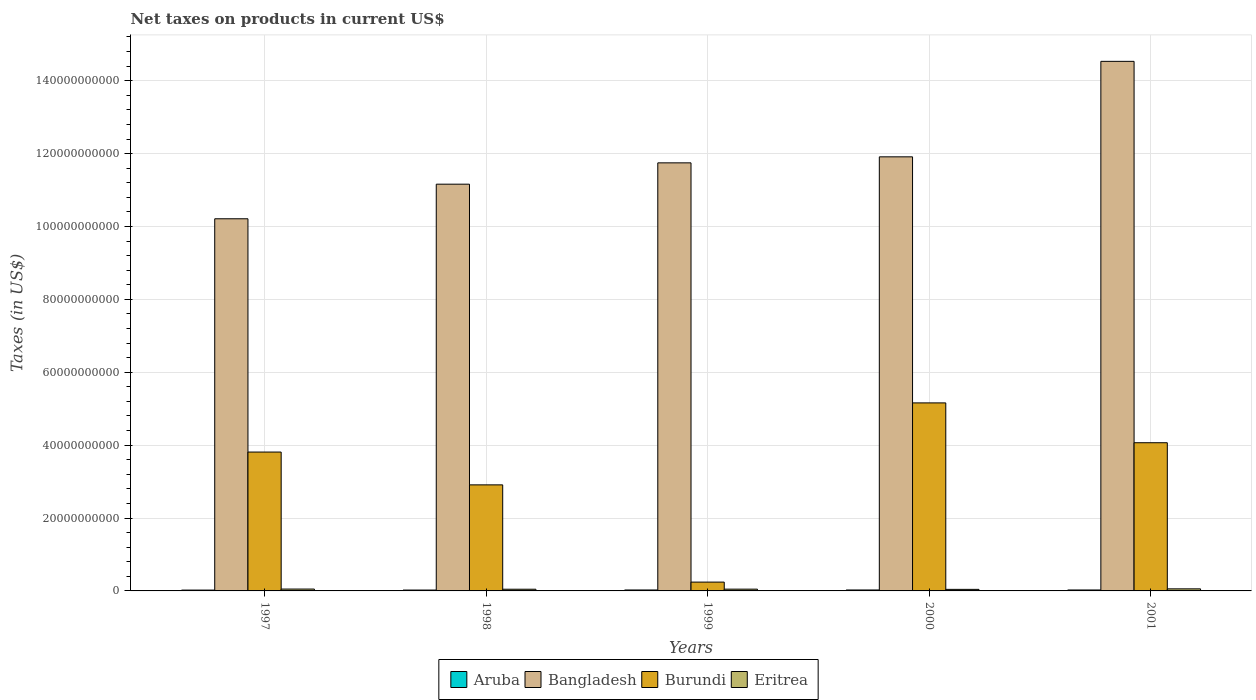How many groups of bars are there?
Offer a terse response. 5. Are the number of bars per tick equal to the number of legend labels?
Keep it short and to the point. Yes. Are the number of bars on each tick of the X-axis equal?
Your answer should be very brief. Yes. How many bars are there on the 5th tick from the left?
Offer a very short reply. 4. How many bars are there on the 4th tick from the right?
Make the answer very short. 4. What is the label of the 2nd group of bars from the left?
Keep it short and to the point. 1998. What is the net taxes on products in Eritrea in 2000?
Provide a short and direct response. 4.28e+08. Across all years, what is the maximum net taxes on products in Burundi?
Give a very brief answer. 5.16e+1. Across all years, what is the minimum net taxes on products in Bangladesh?
Provide a short and direct response. 1.02e+11. In which year was the net taxes on products in Bangladesh maximum?
Provide a short and direct response. 2001. In which year was the net taxes on products in Aruba minimum?
Your answer should be compact. 1997. What is the total net taxes on products in Aruba in the graph?
Make the answer very short. 1.24e+09. What is the difference between the net taxes on products in Bangladesh in 1999 and that in 2001?
Keep it short and to the point. -2.78e+1. What is the difference between the net taxes on products in Burundi in 2001 and the net taxes on products in Eritrea in 1999?
Make the answer very short. 4.02e+1. What is the average net taxes on products in Burundi per year?
Provide a short and direct response. 3.24e+1. In the year 2000, what is the difference between the net taxes on products in Burundi and net taxes on products in Aruba?
Ensure brevity in your answer.  5.13e+1. In how many years, is the net taxes on products in Bangladesh greater than 20000000000 US$?
Make the answer very short. 5. What is the ratio of the net taxes on products in Eritrea in 1998 to that in 2000?
Your answer should be compact. 1.09. Is the net taxes on products in Burundi in 1999 less than that in 2000?
Keep it short and to the point. Yes. What is the difference between the highest and the second highest net taxes on products in Burundi?
Provide a succinct answer. 1.09e+1. What is the difference between the highest and the lowest net taxes on products in Burundi?
Ensure brevity in your answer.  4.92e+1. In how many years, is the net taxes on products in Burundi greater than the average net taxes on products in Burundi taken over all years?
Your answer should be very brief. 3. Is the sum of the net taxes on products in Burundi in 1997 and 1998 greater than the maximum net taxes on products in Bangladesh across all years?
Offer a terse response. No. Is it the case that in every year, the sum of the net taxes on products in Eritrea and net taxes on products in Bangladesh is greater than the sum of net taxes on products in Burundi and net taxes on products in Aruba?
Make the answer very short. Yes. What does the 4th bar from the left in 1997 represents?
Your response must be concise. Eritrea. Is it the case that in every year, the sum of the net taxes on products in Aruba and net taxes on products in Bangladesh is greater than the net taxes on products in Eritrea?
Give a very brief answer. Yes. How many bars are there?
Give a very brief answer. 20. Are all the bars in the graph horizontal?
Offer a terse response. No. How many years are there in the graph?
Your answer should be compact. 5. Are the values on the major ticks of Y-axis written in scientific E-notation?
Your answer should be compact. No. Does the graph contain any zero values?
Ensure brevity in your answer.  No. How many legend labels are there?
Provide a short and direct response. 4. How are the legend labels stacked?
Offer a very short reply. Horizontal. What is the title of the graph?
Your answer should be very brief. Net taxes on products in current US$. What is the label or title of the X-axis?
Make the answer very short. Years. What is the label or title of the Y-axis?
Make the answer very short. Taxes (in US$). What is the Taxes (in US$) in Aruba in 1997?
Your answer should be very brief. 2.29e+08. What is the Taxes (in US$) in Bangladesh in 1997?
Make the answer very short. 1.02e+11. What is the Taxes (in US$) of Burundi in 1997?
Provide a succinct answer. 3.81e+1. What is the Taxes (in US$) of Eritrea in 1997?
Give a very brief answer. 5.11e+08. What is the Taxes (in US$) in Aruba in 1998?
Offer a very short reply. 2.38e+08. What is the Taxes (in US$) in Bangladesh in 1998?
Your answer should be very brief. 1.12e+11. What is the Taxes (in US$) in Burundi in 1998?
Offer a terse response. 2.91e+1. What is the Taxes (in US$) of Eritrea in 1998?
Your response must be concise. 4.65e+08. What is the Taxes (in US$) of Aruba in 1999?
Your answer should be very brief. 2.59e+08. What is the Taxes (in US$) of Bangladesh in 1999?
Your response must be concise. 1.17e+11. What is the Taxes (in US$) in Burundi in 1999?
Your answer should be very brief. 2.42e+09. What is the Taxes (in US$) in Eritrea in 1999?
Offer a terse response. 4.88e+08. What is the Taxes (in US$) in Aruba in 2000?
Offer a terse response. 2.59e+08. What is the Taxes (in US$) of Bangladesh in 2000?
Ensure brevity in your answer.  1.19e+11. What is the Taxes (in US$) of Burundi in 2000?
Give a very brief answer. 5.16e+1. What is the Taxes (in US$) in Eritrea in 2000?
Your response must be concise. 4.28e+08. What is the Taxes (in US$) in Aruba in 2001?
Offer a terse response. 2.58e+08. What is the Taxes (in US$) in Bangladesh in 2001?
Your answer should be very brief. 1.45e+11. What is the Taxes (in US$) in Burundi in 2001?
Your response must be concise. 4.07e+1. What is the Taxes (in US$) of Eritrea in 2001?
Ensure brevity in your answer.  5.68e+08. Across all years, what is the maximum Taxes (in US$) of Aruba?
Provide a succinct answer. 2.59e+08. Across all years, what is the maximum Taxes (in US$) in Bangladesh?
Provide a short and direct response. 1.45e+11. Across all years, what is the maximum Taxes (in US$) in Burundi?
Your answer should be very brief. 5.16e+1. Across all years, what is the maximum Taxes (in US$) in Eritrea?
Offer a terse response. 5.68e+08. Across all years, what is the minimum Taxes (in US$) in Aruba?
Your answer should be compact. 2.29e+08. Across all years, what is the minimum Taxes (in US$) in Bangladesh?
Ensure brevity in your answer.  1.02e+11. Across all years, what is the minimum Taxes (in US$) in Burundi?
Provide a succinct answer. 2.42e+09. Across all years, what is the minimum Taxes (in US$) in Eritrea?
Your answer should be very brief. 4.28e+08. What is the total Taxes (in US$) in Aruba in the graph?
Keep it short and to the point. 1.24e+09. What is the total Taxes (in US$) in Bangladesh in the graph?
Your response must be concise. 5.96e+11. What is the total Taxes (in US$) in Burundi in the graph?
Give a very brief answer. 1.62e+11. What is the total Taxes (in US$) in Eritrea in the graph?
Make the answer very short. 2.46e+09. What is the difference between the Taxes (in US$) of Aruba in 1997 and that in 1998?
Keep it short and to the point. -9.46e+06. What is the difference between the Taxes (in US$) in Bangladesh in 1997 and that in 1998?
Offer a very short reply. -9.50e+09. What is the difference between the Taxes (in US$) in Burundi in 1997 and that in 1998?
Your answer should be compact. 9.00e+09. What is the difference between the Taxes (in US$) in Eritrea in 1997 and that in 1998?
Offer a terse response. 4.67e+07. What is the difference between the Taxes (in US$) of Aruba in 1997 and that in 1999?
Provide a short and direct response. -2.98e+07. What is the difference between the Taxes (in US$) of Bangladesh in 1997 and that in 1999?
Your response must be concise. -1.53e+1. What is the difference between the Taxes (in US$) of Burundi in 1997 and that in 1999?
Your response must be concise. 3.57e+1. What is the difference between the Taxes (in US$) of Eritrea in 1997 and that in 1999?
Your answer should be very brief. 2.40e+07. What is the difference between the Taxes (in US$) of Aruba in 1997 and that in 2000?
Provide a succinct answer. -2.98e+07. What is the difference between the Taxes (in US$) of Bangladesh in 1997 and that in 2000?
Ensure brevity in your answer.  -1.70e+1. What is the difference between the Taxes (in US$) of Burundi in 1997 and that in 2000?
Ensure brevity in your answer.  -1.35e+1. What is the difference between the Taxes (in US$) in Eritrea in 1997 and that in 2000?
Ensure brevity in your answer.  8.38e+07. What is the difference between the Taxes (in US$) in Aruba in 1997 and that in 2001?
Offer a very short reply. -2.92e+07. What is the difference between the Taxes (in US$) of Bangladesh in 1997 and that in 2001?
Offer a terse response. -4.32e+1. What is the difference between the Taxes (in US$) of Burundi in 1997 and that in 2001?
Your response must be concise. -2.56e+09. What is the difference between the Taxes (in US$) in Eritrea in 1997 and that in 2001?
Your answer should be very brief. -5.66e+07. What is the difference between the Taxes (in US$) of Aruba in 1998 and that in 1999?
Your answer should be compact. -2.03e+07. What is the difference between the Taxes (in US$) of Bangladesh in 1998 and that in 1999?
Your answer should be very brief. -5.85e+09. What is the difference between the Taxes (in US$) in Burundi in 1998 and that in 1999?
Provide a short and direct response. 2.67e+1. What is the difference between the Taxes (in US$) in Eritrea in 1998 and that in 1999?
Provide a succinct answer. -2.27e+07. What is the difference between the Taxes (in US$) in Aruba in 1998 and that in 2000?
Ensure brevity in your answer.  -2.03e+07. What is the difference between the Taxes (in US$) in Bangladesh in 1998 and that in 2000?
Provide a short and direct response. -7.50e+09. What is the difference between the Taxes (in US$) in Burundi in 1998 and that in 2000?
Your answer should be compact. -2.25e+1. What is the difference between the Taxes (in US$) in Eritrea in 1998 and that in 2000?
Your answer should be compact. 3.71e+07. What is the difference between the Taxes (in US$) of Aruba in 1998 and that in 2001?
Your response must be concise. -1.97e+07. What is the difference between the Taxes (in US$) in Bangladesh in 1998 and that in 2001?
Your response must be concise. -3.37e+1. What is the difference between the Taxes (in US$) in Burundi in 1998 and that in 2001?
Keep it short and to the point. -1.16e+1. What is the difference between the Taxes (in US$) of Eritrea in 1998 and that in 2001?
Ensure brevity in your answer.  -1.03e+08. What is the difference between the Taxes (in US$) of Aruba in 1999 and that in 2000?
Offer a very short reply. 0. What is the difference between the Taxes (in US$) in Bangladesh in 1999 and that in 2000?
Make the answer very short. -1.65e+09. What is the difference between the Taxes (in US$) of Burundi in 1999 and that in 2000?
Ensure brevity in your answer.  -4.92e+1. What is the difference between the Taxes (in US$) in Eritrea in 1999 and that in 2000?
Offer a very short reply. 5.98e+07. What is the difference between the Taxes (in US$) of Aruba in 1999 and that in 2001?
Provide a succinct answer. 5.80e+05. What is the difference between the Taxes (in US$) in Bangladesh in 1999 and that in 2001?
Ensure brevity in your answer.  -2.78e+1. What is the difference between the Taxes (in US$) of Burundi in 1999 and that in 2001?
Your answer should be very brief. -3.82e+1. What is the difference between the Taxes (in US$) in Eritrea in 1999 and that in 2001?
Ensure brevity in your answer.  -8.06e+07. What is the difference between the Taxes (in US$) in Aruba in 2000 and that in 2001?
Ensure brevity in your answer.  5.80e+05. What is the difference between the Taxes (in US$) in Bangladesh in 2000 and that in 2001?
Provide a short and direct response. -2.62e+1. What is the difference between the Taxes (in US$) in Burundi in 2000 and that in 2001?
Keep it short and to the point. 1.09e+1. What is the difference between the Taxes (in US$) of Eritrea in 2000 and that in 2001?
Your answer should be compact. -1.40e+08. What is the difference between the Taxes (in US$) in Aruba in 1997 and the Taxes (in US$) in Bangladesh in 1998?
Give a very brief answer. -1.11e+11. What is the difference between the Taxes (in US$) of Aruba in 1997 and the Taxes (in US$) of Burundi in 1998?
Your response must be concise. -2.89e+1. What is the difference between the Taxes (in US$) in Aruba in 1997 and the Taxes (in US$) in Eritrea in 1998?
Offer a terse response. -2.36e+08. What is the difference between the Taxes (in US$) of Bangladesh in 1997 and the Taxes (in US$) of Burundi in 1998?
Provide a succinct answer. 7.30e+1. What is the difference between the Taxes (in US$) of Bangladesh in 1997 and the Taxes (in US$) of Eritrea in 1998?
Offer a very short reply. 1.02e+11. What is the difference between the Taxes (in US$) in Burundi in 1997 and the Taxes (in US$) in Eritrea in 1998?
Give a very brief answer. 3.76e+1. What is the difference between the Taxes (in US$) of Aruba in 1997 and the Taxes (in US$) of Bangladesh in 1999?
Your answer should be compact. -1.17e+11. What is the difference between the Taxes (in US$) of Aruba in 1997 and the Taxes (in US$) of Burundi in 1999?
Provide a succinct answer. -2.19e+09. What is the difference between the Taxes (in US$) in Aruba in 1997 and the Taxes (in US$) in Eritrea in 1999?
Give a very brief answer. -2.58e+08. What is the difference between the Taxes (in US$) in Bangladesh in 1997 and the Taxes (in US$) in Burundi in 1999?
Give a very brief answer. 9.97e+1. What is the difference between the Taxes (in US$) of Bangladesh in 1997 and the Taxes (in US$) of Eritrea in 1999?
Your response must be concise. 1.02e+11. What is the difference between the Taxes (in US$) of Burundi in 1997 and the Taxes (in US$) of Eritrea in 1999?
Make the answer very short. 3.76e+1. What is the difference between the Taxes (in US$) in Aruba in 1997 and the Taxes (in US$) in Bangladesh in 2000?
Your response must be concise. -1.19e+11. What is the difference between the Taxes (in US$) of Aruba in 1997 and the Taxes (in US$) of Burundi in 2000?
Your response must be concise. -5.14e+1. What is the difference between the Taxes (in US$) in Aruba in 1997 and the Taxes (in US$) in Eritrea in 2000?
Your response must be concise. -1.99e+08. What is the difference between the Taxes (in US$) of Bangladesh in 1997 and the Taxes (in US$) of Burundi in 2000?
Provide a succinct answer. 5.05e+1. What is the difference between the Taxes (in US$) in Bangladesh in 1997 and the Taxes (in US$) in Eritrea in 2000?
Provide a succinct answer. 1.02e+11. What is the difference between the Taxes (in US$) in Burundi in 1997 and the Taxes (in US$) in Eritrea in 2000?
Make the answer very short. 3.77e+1. What is the difference between the Taxes (in US$) in Aruba in 1997 and the Taxes (in US$) in Bangladesh in 2001?
Offer a terse response. -1.45e+11. What is the difference between the Taxes (in US$) in Aruba in 1997 and the Taxes (in US$) in Burundi in 2001?
Keep it short and to the point. -4.04e+1. What is the difference between the Taxes (in US$) of Aruba in 1997 and the Taxes (in US$) of Eritrea in 2001?
Keep it short and to the point. -3.39e+08. What is the difference between the Taxes (in US$) of Bangladesh in 1997 and the Taxes (in US$) of Burundi in 2001?
Provide a succinct answer. 6.15e+1. What is the difference between the Taxes (in US$) of Bangladesh in 1997 and the Taxes (in US$) of Eritrea in 2001?
Give a very brief answer. 1.02e+11. What is the difference between the Taxes (in US$) in Burundi in 1997 and the Taxes (in US$) in Eritrea in 2001?
Keep it short and to the point. 3.75e+1. What is the difference between the Taxes (in US$) of Aruba in 1998 and the Taxes (in US$) of Bangladesh in 1999?
Your answer should be compact. -1.17e+11. What is the difference between the Taxes (in US$) of Aruba in 1998 and the Taxes (in US$) of Burundi in 1999?
Offer a terse response. -2.18e+09. What is the difference between the Taxes (in US$) in Aruba in 1998 and the Taxes (in US$) in Eritrea in 1999?
Make the answer very short. -2.49e+08. What is the difference between the Taxes (in US$) of Bangladesh in 1998 and the Taxes (in US$) of Burundi in 1999?
Offer a terse response. 1.09e+11. What is the difference between the Taxes (in US$) of Bangladesh in 1998 and the Taxes (in US$) of Eritrea in 1999?
Your answer should be very brief. 1.11e+11. What is the difference between the Taxes (in US$) in Burundi in 1998 and the Taxes (in US$) in Eritrea in 1999?
Make the answer very short. 2.86e+1. What is the difference between the Taxes (in US$) of Aruba in 1998 and the Taxes (in US$) of Bangladesh in 2000?
Provide a succinct answer. -1.19e+11. What is the difference between the Taxes (in US$) of Aruba in 1998 and the Taxes (in US$) of Burundi in 2000?
Your answer should be compact. -5.14e+1. What is the difference between the Taxes (in US$) of Aruba in 1998 and the Taxes (in US$) of Eritrea in 2000?
Make the answer very short. -1.89e+08. What is the difference between the Taxes (in US$) of Bangladesh in 1998 and the Taxes (in US$) of Burundi in 2000?
Your answer should be very brief. 6.00e+1. What is the difference between the Taxes (in US$) in Bangladesh in 1998 and the Taxes (in US$) in Eritrea in 2000?
Ensure brevity in your answer.  1.11e+11. What is the difference between the Taxes (in US$) of Burundi in 1998 and the Taxes (in US$) of Eritrea in 2000?
Provide a succinct answer. 2.87e+1. What is the difference between the Taxes (in US$) of Aruba in 1998 and the Taxes (in US$) of Bangladesh in 2001?
Give a very brief answer. -1.45e+11. What is the difference between the Taxes (in US$) in Aruba in 1998 and the Taxes (in US$) in Burundi in 2001?
Give a very brief answer. -4.04e+1. What is the difference between the Taxes (in US$) of Aruba in 1998 and the Taxes (in US$) of Eritrea in 2001?
Your response must be concise. -3.30e+08. What is the difference between the Taxes (in US$) of Bangladesh in 1998 and the Taxes (in US$) of Burundi in 2001?
Your answer should be very brief. 7.09e+1. What is the difference between the Taxes (in US$) of Bangladesh in 1998 and the Taxes (in US$) of Eritrea in 2001?
Ensure brevity in your answer.  1.11e+11. What is the difference between the Taxes (in US$) in Burundi in 1998 and the Taxes (in US$) in Eritrea in 2001?
Make the answer very short. 2.85e+1. What is the difference between the Taxes (in US$) of Aruba in 1999 and the Taxes (in US$) of Bangladesh in 2000?
Your answer should be compact. -1.19e+11. What is the difference between the Taxes (in US$) of Aruba in 1999 and the Taxes (in US$) of Burundi in 2000?
Keep it short and to the point. -5.13e+1. What is the difference between the Taxes (in US$) in Aruba in 1999 and the Taxes (in US$) in Eritrea in 2000?
Offer a very short reply. -1.69e+08. What is the difference between the Taxes (in US$) in Bangladesh in 1999 and the Taxes (in US$) in Burundi in 2000?
Provide a short and direct response. 6.59e+1. What is the difference between the Taxes (in US$) in Bangladesh in 1999 and the Taxes (in US$) in Eritrea in 2000?
Give a very brief answer. 1.17e+11. What is the difference between the Taxes (in US$) of Burundi in 1999 and the Taxes (in US$) of Eritrea in 2000?
Your answer should be very brief. 1.99e+09. What is the difference between the Taxes (in US$) of Aruba in 1999 and the Taxes (in US$) of Bangladesh in 2001?
Offer a terse response. -1.45e+11. What is the difference between the Taxes (in US$) of Aruba in 1999 and the Taxes (in US$) of Burundi in 2001?
Provide a short and direct response. -4.04e+1. What is the difference between the Taxes (in US$) of Aruba in 1999 and the Taxes (in US$) of Eritrea in 2001?
Give a very brief answer. -3.09e+08. What is the difference between the Taxes (in US$) in Bangladesh in 1999 and the Taxes (in US$) in Burundi in 2001?
Your response must be concise. 7.68e+1. What is the difference between the Taxes (in US$) in Bangladesh in 1999 and the Taxes (in US$) in Eritrea in 2001?
Make the answer very short. 1.17e+11. What is the difference between the Taxes (in US$) in Burundi in 1999 and the Taxes (in US$) in Eritrea in 2001?
Your response must be concise. 1.85e+09. What is the difference between the Taxes (in US$) in Aruba in 2000 and the Taxes (in US$) in Bangladesh in 2001?
Provide a succinct answer. -1.45e+11. What is the difference between the Taxes (in US$) in Aruba in 2000 and the Taxes (in US$) in Burundi in 2001?
Make the answer very short. -4.04e+1. What is the difference between the Taxes (in US$) in Aruba in 2000 and the Taxes (in US$) in Eritrea in 2001?
Your answer should be compact. -3.09e+08. What is the difference between the Taxes (in US$) of Bangladesh in 2000 and the Taxes (in US$) of Burundi in 2001?
Offer a very short reply. 7.85e+1. What is the difference between the Taxes (in US$) in Bangladesh in 2000 and the Taxes (in US$) in Eritrea in 2001?
Your answer should be compact. 1.19e+11. What is the difference between the Taxes (in US$) of Burundi in 2000 and the Taxes (in US$) of Eritrea in 2001?
Provide a succinct answer. 5.10e+1. What is the average Taxes (in US$) in Aruba per year?
Ensure brevity in your answer.  2.49e+08. What is the average Taxes (in US$) of Bangladesh per year?
Provide a succinct answer. 1.19e+11. What is the average Taxes (in US$) of Burundi per year?
Keep it short and to the point. 3.24e+1. What is the average Taxes (in US$) in Eritrea per year?
Your answer should be very brief. 4.92e+08. In the year 1997, what is the difference between the Taxes (in US$) in Aruba and Taxes (in US$) in Bangladesh?
Provide a succinct answer. -1.02e+11. In the year 1997, what is the difference between the Taxes (in US$) of Aruba and Taxes (in US$) of Burundi?
Make the answer very short. -3.79e+1. In the year 1997, what is the difference between the Taxes (in US$) of Aruba and Taxes (in US$) of Eritrea?
Provide a succinct answer. -2.82e+08. In the year 1997, what is the difference between the Taxes (in US$) in Bangladesh and Taxes (in US$) in Burundi?
Offer a terse response. 6.40e+1. In the year 1997, what is the difference between the Taxes (in US$) in Bangladesh and Taxes (in US$) in Eritrea?
Give a very brief answer. 1.02e+11. In the year 1997, what is the difference between the Taxes (in US$) of Burundi and Taxes (in US$) of Eritrea?
Your response must be concise. 3.76e+1. In the year 1998, what is the difference between the Taxes (in US$) in Aruba and Taxes (in US$) in Bangladesh?
Offer a very short reply. -1.11e+11. In the year 1998, what is the difference between the Taxes (in US$) of Aruba and Taxes (in US$) of Burundi?
Make the answer very short. -2.89e+1. In the year 1998, what is the difference between the Taxes (in US$) in Aruba and Taxes (in US$) in Eritrea?
Provide a succinct answer. -2.26e+08. In the year 1998, what is the difference between the Taxes (in US$) of Bangladesh and Taxes (in US$) of Burundi?
Provide a short and direct response. 8.25e+1. In the year 1998, what is the difference between the Taxes (in US$) of Bangladesh and Taxes (in US$) of Eritrea?
Ensure brevity in your answer.  1.11e+11. In the year 1998, what is the difference between the Taxes (in US$) in Burundi and Taxes (in US$) in Eritrea?
Offer a very short reply. 2.86e+1. In the year 1999, what is the difference between the Taxes (in US$) in Aruba and Taxes (in US$) in Bangladesh?
Your answer should be very brief. -1.17e+11. In the year 1999, what is the difference between the Taxes (in US$) in Aruba and Taxes (in US$) in Burundi?
Offer a terse response. -2.16e+09. In the year 1999, what is the difference between the Taxes (in US$) in Aruba and Taxes (in US$) in Eritrea?
Offer a very short reply. -2.29e+08. In the year 1999, what is the difference between the Taxes (in US$) of Bangladesh and Taxes (in US$) of Burundi?
Provide a short and direct response. 1.15e+11. In the year 1999, what is the difference between the Taxes (in US$) of Bangladesh and Taxes (in US$) of Eritrea?
Ensure brevity in your answer.  1.17e+11. In the year 1999, what is the difference between the Taxes (in US$) in Burundi and Taxes (in US$) in Eritrea?
Provide a short and direct response. 1.93e+09. In the year 2000, what is the difference between the Taxes (in US$) in Aruba and Taxes (in US$) in Bangladesh?
Provide a short and direct response. -1.19e+11. In the year 2000, what is the difference between the Taxes (in US$) of Aruba and Taxes (in US$) of Burundi?
Give a very brief answer. -5.13e+1. In the year 2000, what is the difference between the Taxes (in US$) in Aruba and Taxes (in US$) in Eritrea?
Offer a terse response. -1.69e+08. In the year 2000, what is the difference between the Taxes (in US$) in Bangladesh and Taxes (in US$) in Burundi?
Keep it short and to the point. 6.75e+1. In the year 2000, what is the difference between the Taxes (in US$) in Bangladesh and Taxes (in US$) in Eritrea?
Make the answer very short. 1.19e+11. In the year 2000, what is the difference between the Taxes (in US$) in Burundi and Taxes (in US$) in Eritrea?
Your answer should be compact. 5.12e+1. In the year 2001, what is the difference between the Taxes (in US$) in Aruba and Taxes (in US$) in Bangladesh?
Your answer should be very brief. -1.45e+11. In the year 2001, what is the difference between the Taxes (in US$) in Aruba and Taxes (in US$) in Burundi?
Your answer should be compact. -4.04e+1. In the year 2001, what is the difference between the Taxes (in US$) in Aruba and Taxes (in US$) in Eritrea?
Your response must be concise. -3.10e+08. In the year 2001, what is the difference between the Taxes (in US$) of Bangladesh and Taxes (in US$) of Burundi?
Give a very brief answer. 1.05e+11. In the year 2001, what is the difference between the Taxes (in US$) in Bangladesh and Taxes (in US$) in Eritrea?
Your answer should be very brief. 1.45e+11. In the year 2001, what is the difference between the Taxes (in US$) of Burundi and Taxes (in US$) of Eritrea?
Ensure brevity in your answer.  4.01e+1. What is the ratio of the Taxes (in US$) in Aruba in 1997 to that in 1998?
Give a very brief answer. 0.96. What is the ratio of the Taxes (in US$) in Bangladesh in 1997 to that in 1998?
Give a very brief answer. 0.91. What is the ratio of the Taxes (in US$) in Burundi in 1997 to that in 1998?
Your response must be concise. 1.31. What is the ratio of the Taxes (in US$) in Eritrea in 1997 to that in 1998?
Provide a short and direct response. 1.1. What is the ratio of the Taxes (in US$) of Aruba in 1997 to that in 1999?
Your answer should be compact. 0.89. What is the ratio of the Taxes (in US$) of Bangladesh in 1997 to that in 1999?
Your answer should be compact. 0.87. What is the ratio of the Taxes (in US$) of Burundi in 1997 to that in 1999?
Give a very brief answer. 15.74. What is the ratio of the Taxes (in US$) in Eritrea in 1997 to that in 1999?
Provide a short and direct response. 1.05. What is the ratio of the Taxes (in US$) in Aruba in 1997 to that in 2000?
Offer a very short reply. 0.89. What is the ratio of the Taxes (in US$) of Bangladesh in 1997 to that in 2000?
Your response must be concise. 0.86. What is the ratio of the Taxes (in US$) in Burundi in 1997 to that in 2000?
Your response must be concise. 0.74. What is the ratio of the Taxes (in US$) in Eritrea in 1997 to that in 2000?
Keep it short and to the point. 1.2. What is the ratio of the Taxes (in US$) in Aruba in 1997 to that in 2001?
Provide a short and direct response. 0.89. What is the ratio of the Taxes (in US$) of Bangladesh in 1997 to that in 2001?
Provide a short and direct response. 0.7. What is the ratio of the Taxes (in US$) in Burundi in 1997 to that in 2001?
Make the answer very short. 0.94. What is the ratio of the Taxes (in US$) in Eritrea in 1997 to that in 2001?
Ensure brevity in your answer.  0.9. What is the ratio of the Taxes (in US$) in Aruba in 1998 to that in 1999?
Make the answer very short. 0.92. What is the ratio of the Taxes (in US$) in Bangladesh in 1998 to that in 1999?
Provide a short and direct response. 0.95. What is the ratio of the Taxes (in US$) in Burundi in 1998 to that in 1999?
Your response must be concise. 12.02. What is the ratio of the Taxes (in US$) in Eritrea in 1998 to that in 1999?
Keep it short and to the point. 0.95. What is the ratio of the Taxes (in US$) of Aruba in 1998 to that in 2000?
Offer a very short reply. 0.92. What is the ratio of the Taxes (in US$) in Bangladesh in 1998 to that in 2000?
Keep it short and to the point. 0.94. What is the ratio of the Taxes (in US$) in Burundi in 1998 to that in 2000?
Keep it short and to the point. 0.56. What is the ratio of the Taxes (in US$) of Eritrea in 1998 to that in 2000?
Offer a very short reply. 1.09. What is the ratio of the Taxes (in US$) in Aruba in 1998 to that in 2001?
Keep it short and to the point. 0.92. What is the ratio of the Taxes (in US$) of Bangladesh in 1998 to that in 2001?
Offer a terse response. 0.77. What is the ratio of the Taxes (in US$) of Burundi in 1998 to that in 2001?
Offer a terse response. 0.72. What is the ratio of the Taxes (in US$) in Eritrea in 1998 to that in 2001?
Provide a short and direct response. 0.82. What is the ratio of the Taxes (in US$) of Aruba in 1999 to that in 2000?
Your answer should be compact. 1. What is the ratio of the Taxes (in US$) in Bangladesh in 1999 to that in 2000?
Offer a terse response. 0.99. What is the ratio of the Taxes (in US$) in Burundi in 1999 to that in 2000?
Make the answer very short. 0.05. What is the ratio of the Taxes (in US$) of Eritrea in 1999 to that in 2000?
Make the answer very short. 1.14. What is the ratio of the Taxes (in US$) in Aruba in 1999 to that in 2001?
Provide a succinct answer. 1. What is the ratio of the Taxes (in US$) in Bangladesh in 1999 to that in 2001?
Provide a short and direct response. 0.81. What is the ratio of the Taxes (in US$) of Burundi in 1999 to that in 2001?
Give a very brief answer. 0.06. What is the ratio of the Taxes (in US$) of Eritrea in 1999 to that in 2001?
Your answer should be very brief. 0.86. What is the ratio of the Taxes (in US$) in Bangladesh in 2000 to that in 2001?
Your response must be concise. 0.82. What is the ratio of the Taxes (in US$) in Burundi in 2000 to that in 2001?
Offer a terse response. 1.27. What is the ratio of the Taxes (in US$) in Eritrea in 2000 to that in 2001?
Your answer should be very brief. 0.75. What is the difference between the highest and the second highest Taxes (in US$) in Bangladesh?
Give a very brief answer. 2.62e+1. What is the difference between the highest and the second highest Taxes (in US$) of Burundi?
Your answer should be compact. 1.09e+1. What is the difference between the highest and the second highest Taxes (in US$) of Eritrea?
Give a very brief answer. 5.66e+07. What is the difference between the highest and the lowest Taxes (in US$) in Aruba?
Make the answer very short. 2.98e+07. What is the difference between the highest and the lowest Taxes (in US$) of Bangladesh?
Offer a terse response. 4.32e+1. What is the difference between the highest and the lowest Taxes (in US$) of Burundi?
Ensure brevity in your answer.  4.92e+1. What is the difference between the highest and the lowest Taxes (in US$) in Eritrea?
Your answer should be compact. 1.40e+08. 